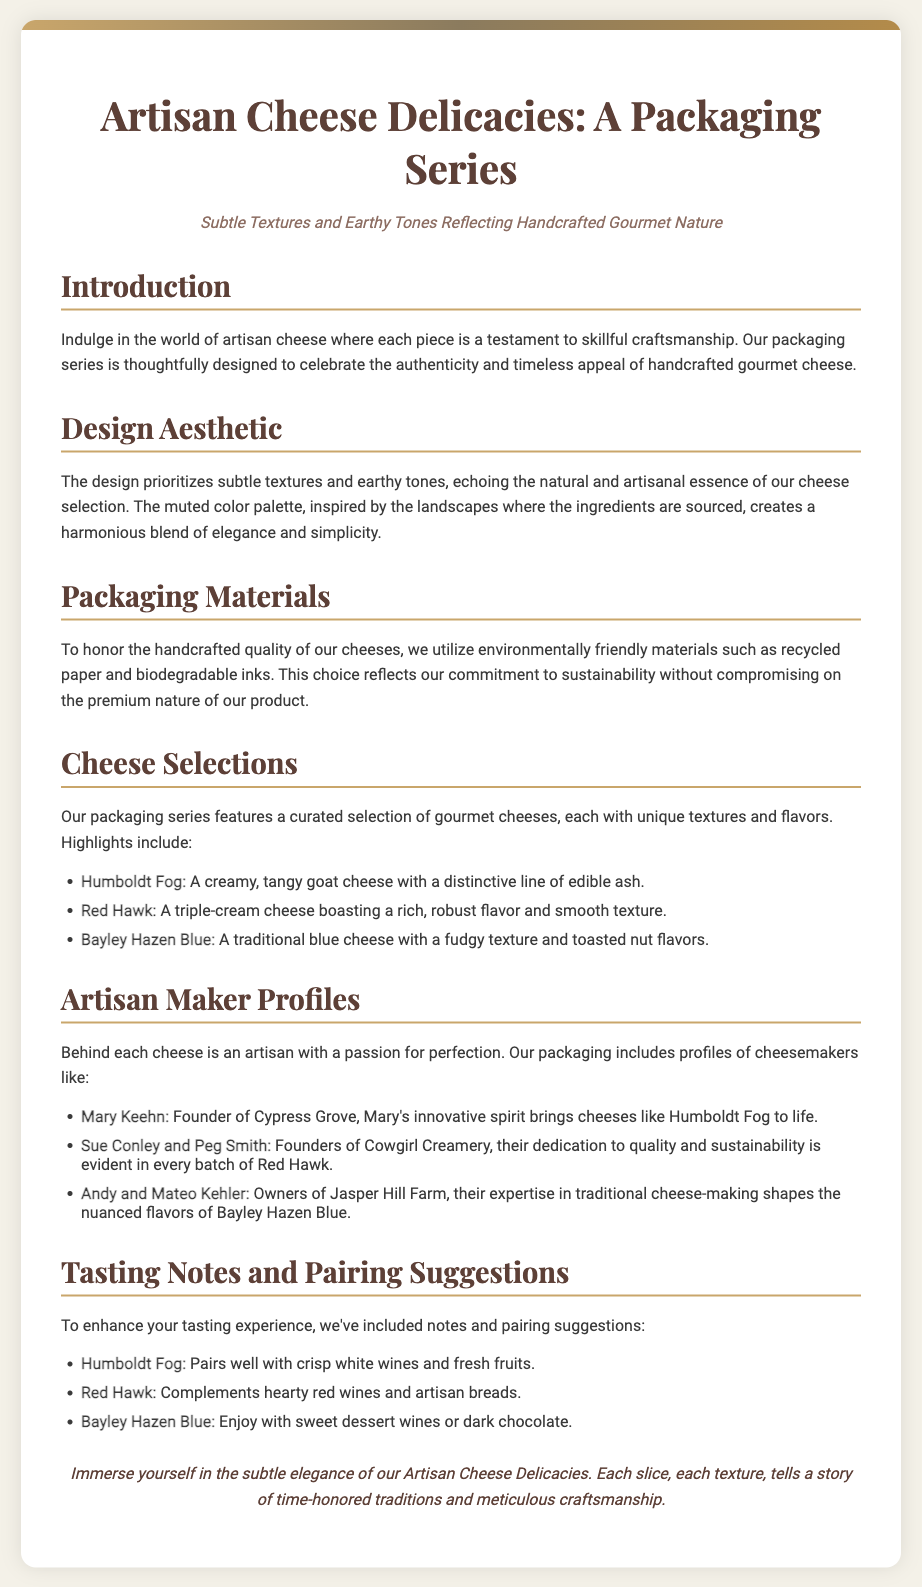What is the title of the packaging series? The title is mentioned prominently at the top of the document, indicating the main focus of the content.
Answer: Artisan Cheese Delicacies: A Packaging Series What design elements are emphasized in the packaging? The document discusses the design aesthetic, highlighting specific attributes that define its visual appeal.
Answer: Subtle textures and earthy tones Who is the founder of Cypress Grove? A specific artisan maker profile in the document provides detailed information about the individual behind one of the featured cheeses.
Answer: Mary Keehn What type of cheese is Humboldt Fog? The document describes each cheese, providing details about their characteristics and flavors.
Answer: Goat cheese Which wine pairs well with Red Hawk cheese? The tasting notes section suggests appropriate pairings for enhancing the cheese-tasting experience.
Answer: Hearty red wines What commitment does the packaging reflect regarding materials? The document addresses the materials used in packaging, explaining an important aspect of sustainability.
Answer: Sustainability How many cheeses are highlighted in the cheese selections? The number of distinct cheeses discussed in the document represents a selection of gourmet options.
Answer: Three What colors inspired the muted palette of the packaging? The section on design mentions the source of inspiration for the color scheme and its connection to the product.
Answer: Landscapes What is the closing remark of the document? The document concludes with a final statement that encapsulates the essence of the artisan cheese offerings.
Answer: Immerse yourself in the subtle elegance of our Artisan Cheese Delicacies 